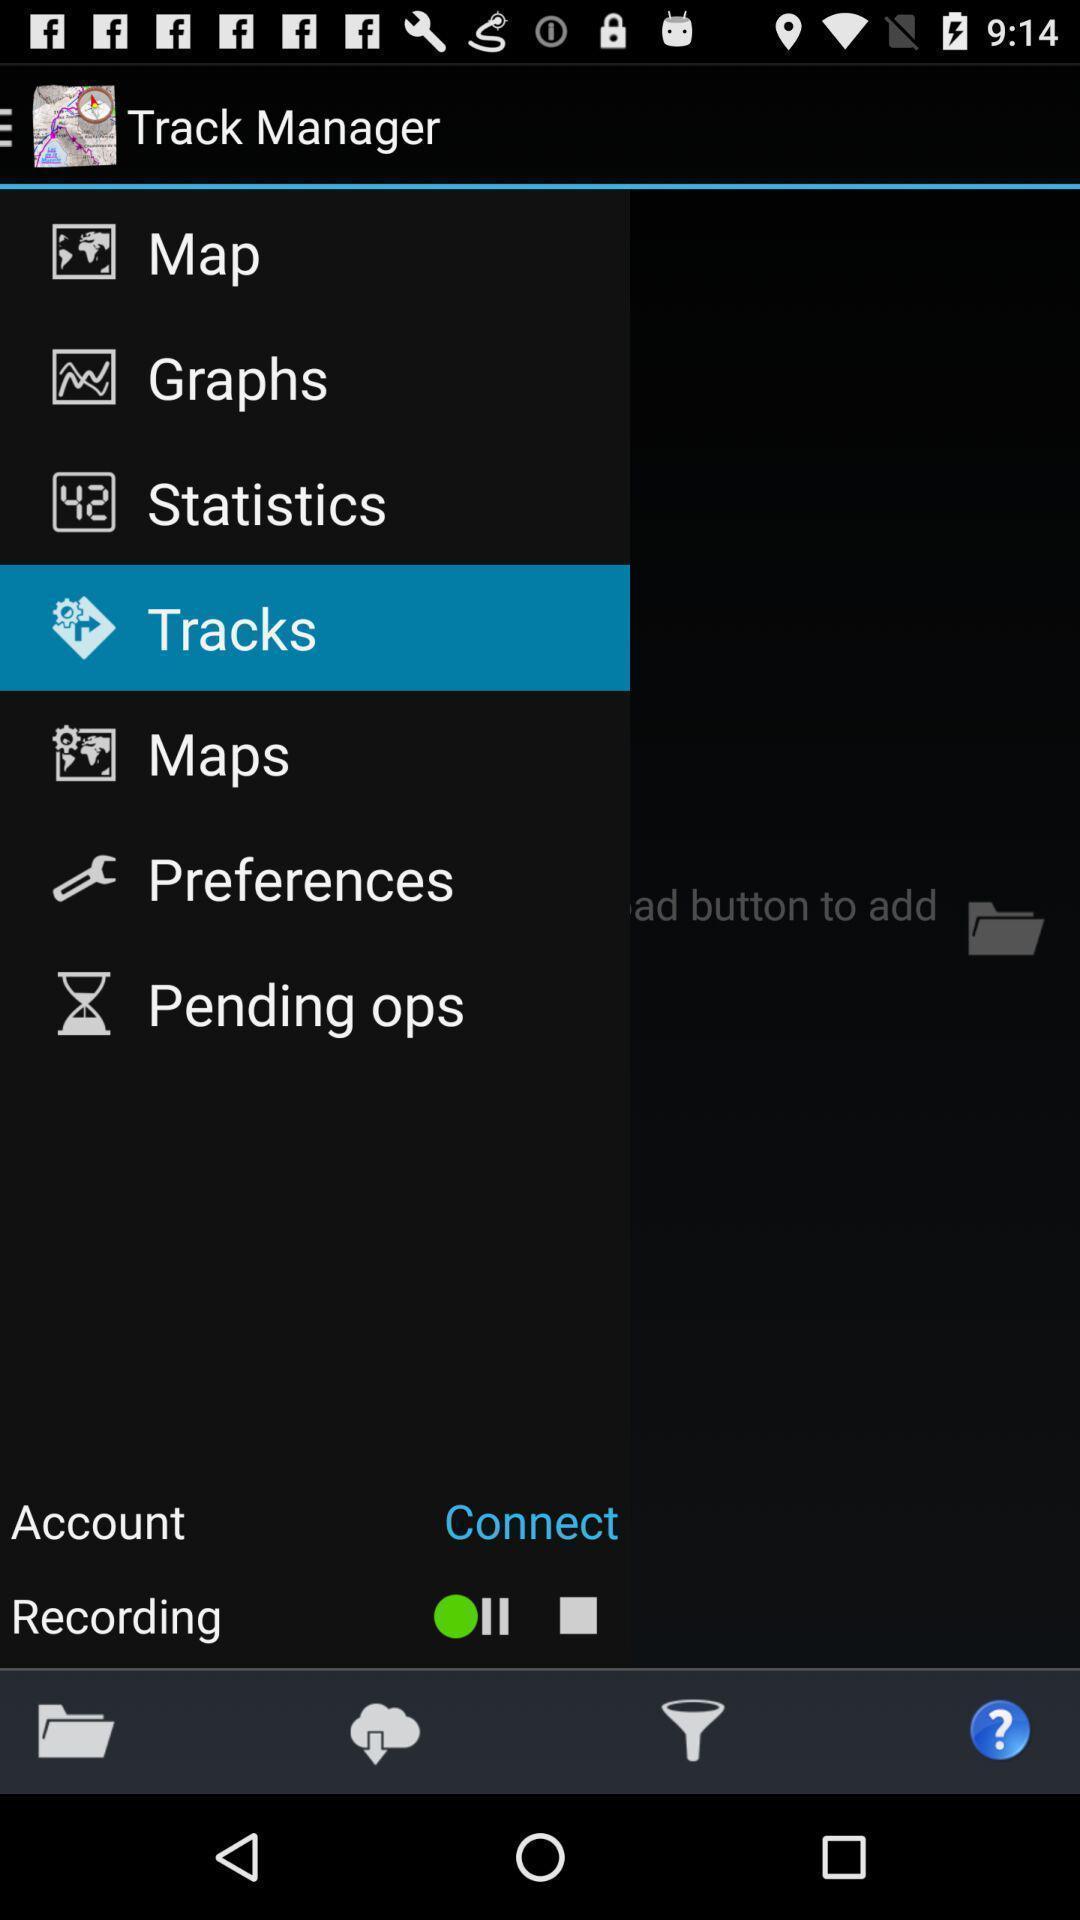Provide a textual representation of this image. Page showing various track manager for gps location tracking app. 